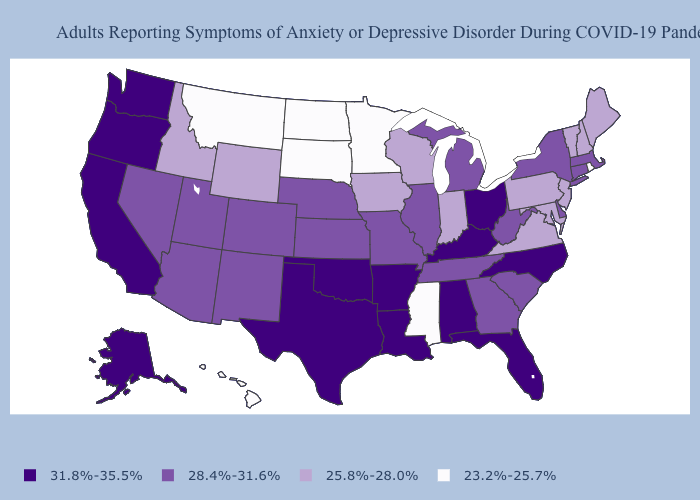What is the value of Minnesota?
Quick response, please. 23.2%-25.7%. Among the states that border Rhode Island , which have the lowest value?
Short answer required. Connecticut, Massachusetts. What is the lowest value in the MidWest?
Answer briefly. 23.2%-25.7%. How many symbols are there in the legend?
Answer briefly. 4. How many symbols are there in the legend?
Be succinct. 4. What is the lowest value in states that border Tennessee?
Answer briefly. 23.2%-25.7%. Which states have the lowest value in the USA?
Concise answer only. Hawaii, Minnesota, Mississippi, Montana, North Dakota, Rhode Island, South Dakota. Among the states that border Michigan , which have the highest value?
Give a very brief answer. Ohio. What is the lowest value in the Northeast?
Be succinct. 23.2%-25.7%. Does Washington have the lowest value in the USA?
Be succinct. No. Does Vermont have a higher value than New Jersey?
Write a very short answer. No. Which states hav the highest value in the MidWest?
Short answer required. Ohio. Name the states that have a value in the range 25.8%-28.0%?
Short answer required. Idaho, Indiana, Iowa, Maine, Maryland, New Hampshire, New Jersey, Pennsylvania, Vermont, Virginia, Wisconsin, Wyoming. Is the legend a continuous bar?
Concise answer only. No. Does Kansas have a higher value than Idaho?
Keep it brief. Yes. 